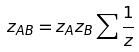Convert formula to latex. <formula><loc_0><loc_0><loc_500><loc_500>z _ { A B } = z _ { A } z _ { B } \sum \frac { 1 } { z }</formula> 